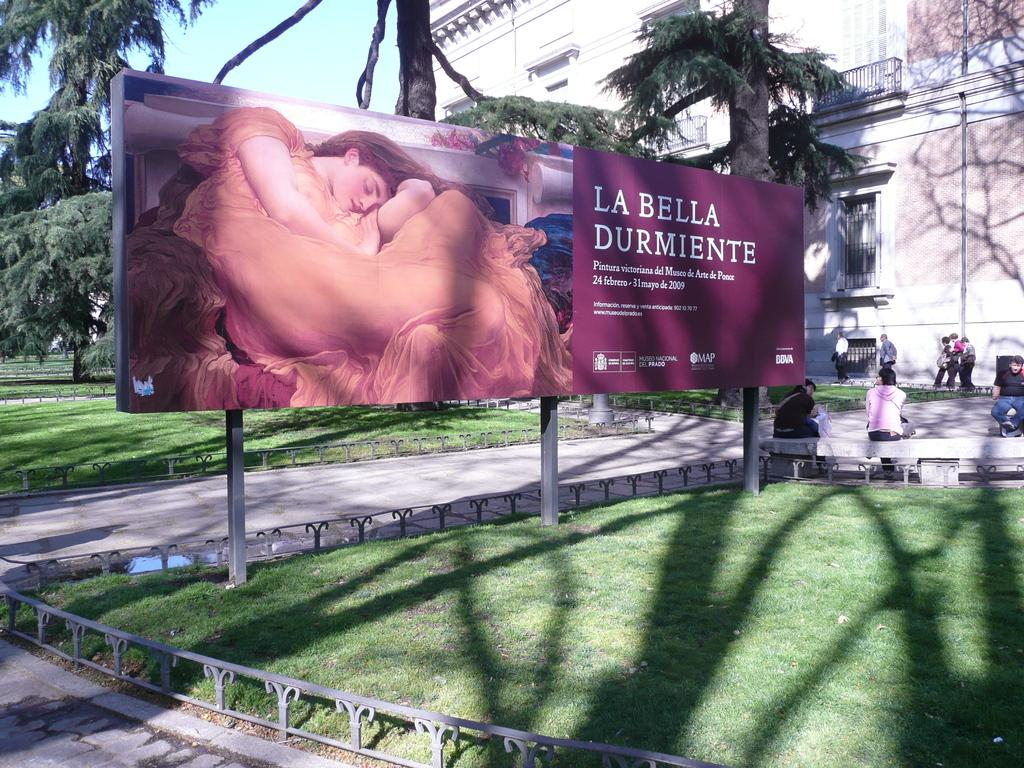<image>
Write a terse but informative summary of the picture. A large red billboard says La Bella Durmiente. 